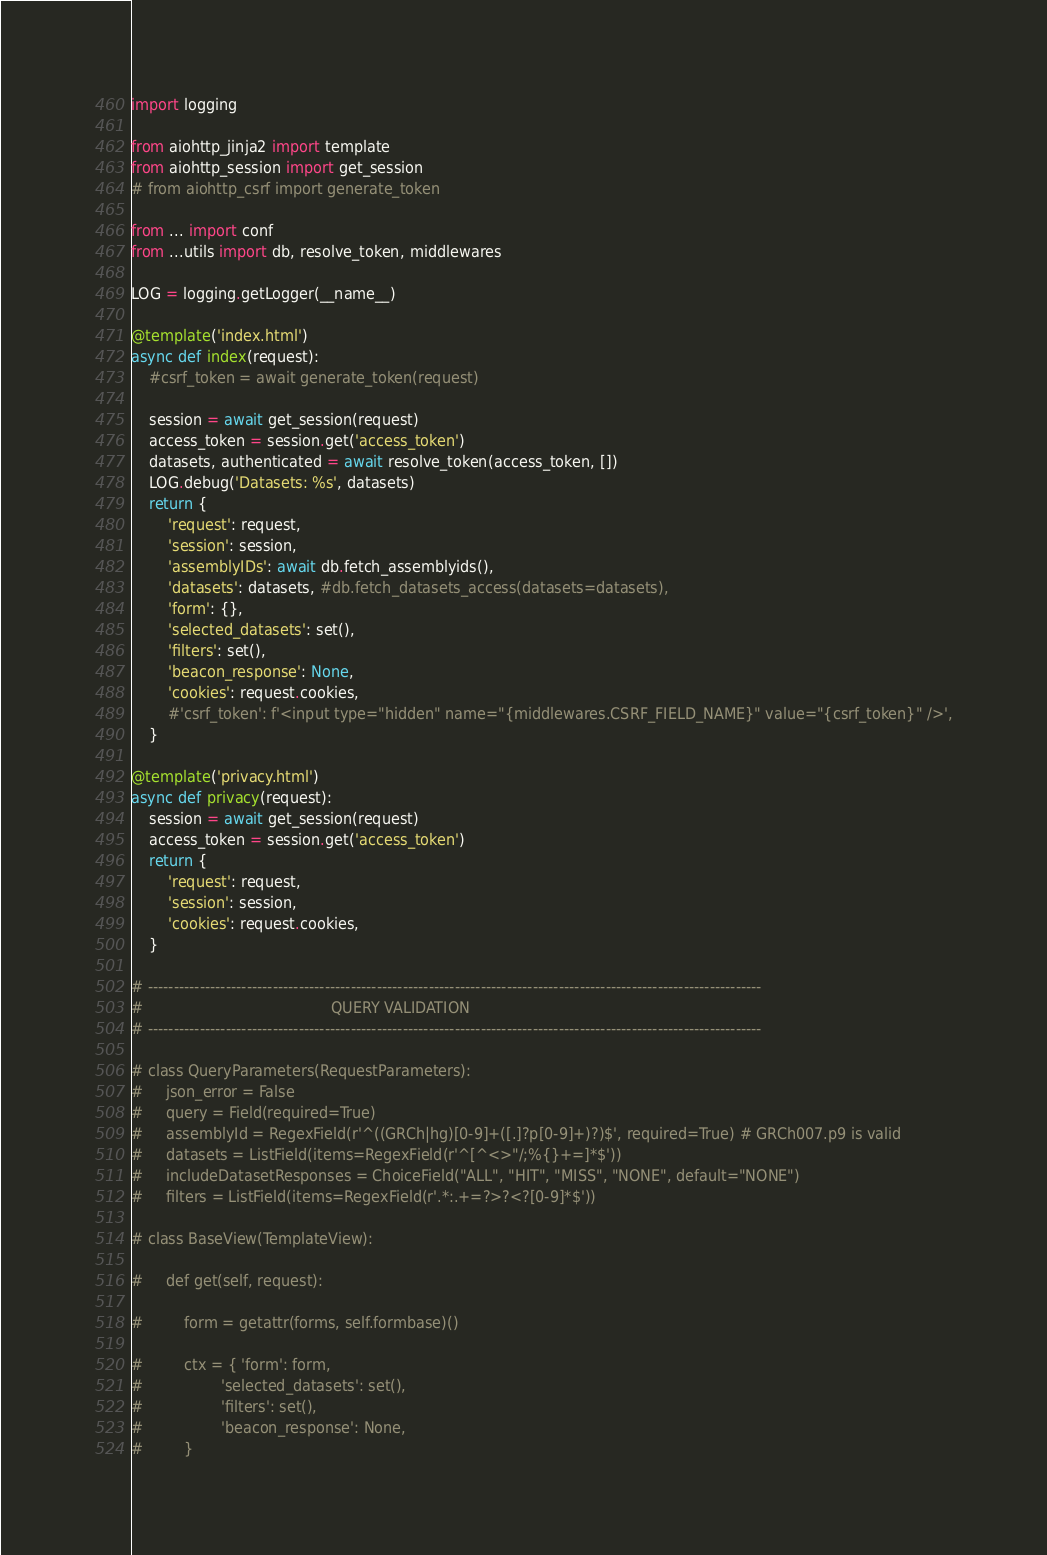<code> <loc_0><loc_0><loc_500><loc_500><_Python_>import logging

from aiohttp_jinja2 import template
from aiohttp_session import get_session
# from aiohttp_csrf import generate_token

from ... import conf
from ...utils import db, resolve_token, middlewares

LOG = logging.getLogger(__name__)

@template('index.html')
async def index(request):
    #csrf_token = await generate_token(request)

    session = await get_session(request)
    access_token = session.get('access_token')
    datasets, authenticated = await resolve_token(access_token, [])
    LOG.debug('Datasets: %s', datasets)
    return {
        'request': request,
        'session': session,
        'assemblyIDs': await db.fetch_assemblyids(),
        'datasets': datasets, #db.fetch_datasets_access(datasets=datasets),
        'form': {},
        'selected_datasets': set(),
        'filters': set(),
        'beacon_response': None,
        'cookies': request.cookies,
        #'csrf_token': f'<input type="hidden" name="{middlewares.CSRF_FIELD_NAME}" value="{csrf_token}" />',
    }

@template('privacy.html')
async def privacy(request):
    session = await get_session(request)
    access_token = session.get('access_token')
    return {
        'request': request,
        'session': session,
        'cookies': request.cookies,
    }

# ----------------------------------------------------------------------------------------------------------------------
#                                         QUERY VALIDATION
# ----------------------------------------------------------------------------------------------------------------------

# class QueryParameters(RequestParameters):
#     json_error = False
#     query = Field(required=True)
#     assemblyId = RegexField(r'^((GRCh|hg)[0-9]+([.]?p[0-9]+)?)$', required=True) # GRCh007.p9 is valid
#     datasets = ListField(items=RegexField(r'^[^<>"/;%{}+=]*$'))
#     includeDatasetResponses = ChoiceField("ALL", "HIT", "MISS", "NONE", default="NONE")
#     filters = ListField(items=RegexField(r'.*:.+=?>?<?[0-9]*$'))

# class BaseView(TemplateView):

#     def get(self, request):

#         form = getattr(forms, self.formbase)()

#         ctx = { 'form': form,
#                 'selected_datasets': set(),
#                 'filters': set(),
#                 'beacon_response': None,
#         }</code> 